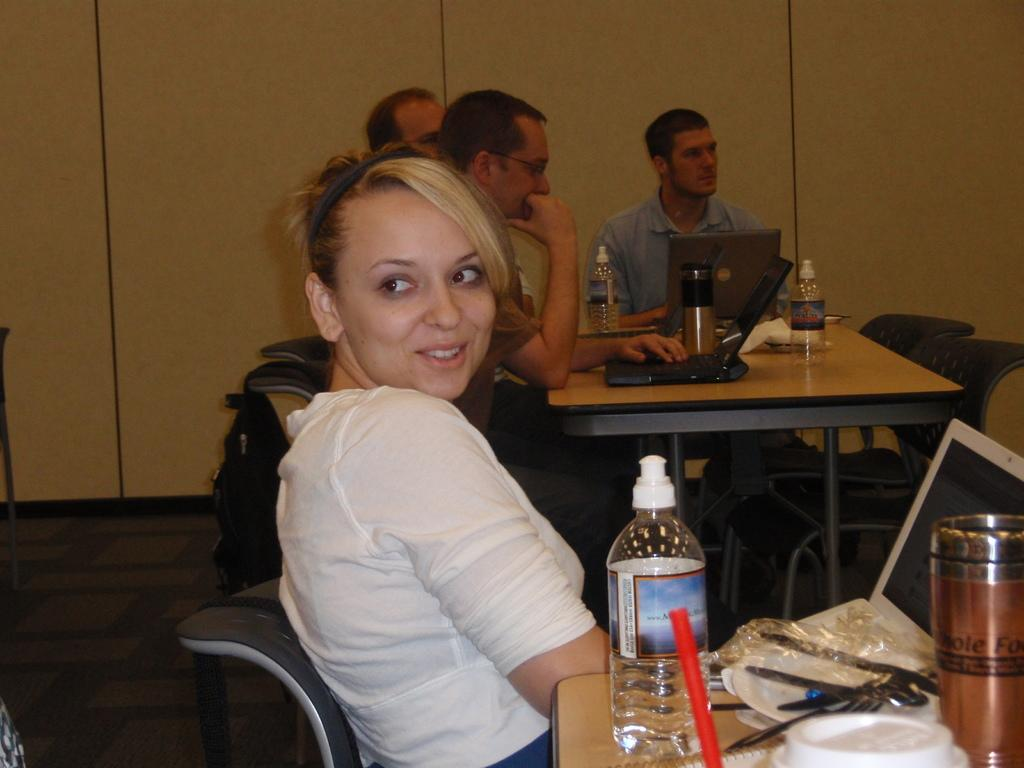How many people are in the image? There is a group of people in the image, but the exact number is not specified. What objects can be seen besides the people? There are bottles, spoons, laptops on a table, and bags at the bottom of the image. What might the people be using the bottles and spoons for? The bottles and spoons could be used for serving or consuming a beverage or food. What are the laptops being used for in the image? The laptops on the table suggest that the people might be working or using them for some purpose. What type of beam is holding up the table in the image? There is no beam visible in the image; it only shows a table with laptops on it. How is the division of labor being managed among the people in the image? There is no information about the division of labor among the people in the image. 